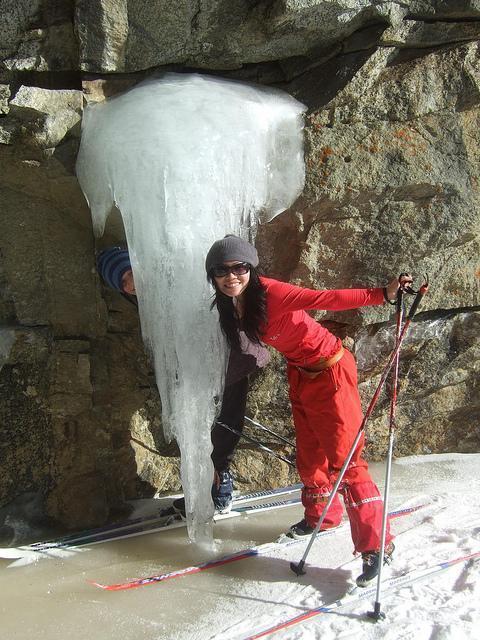How many girls do you see?
Give a very brief answer. 2. How many ski are visible?
Give a very brief answer. 2. How many cars are in the photo?
Give a very brief answer. 0. 